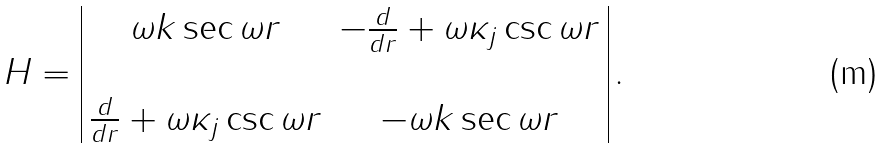Convert formula to latex. <formula><loc_0><loc_0><loc_500><loc_500>H = \begin{array} { | c c | } \omega k \sec \omega r & - \frac { d } { d r } + \omega \kappa _ { j } \csc \omega r \\ & \\ \frac { d } { d r } + \omega \kappa _ { j } \csc \omega r & - \omega k \sec \omega r \end{array} \, .</formula> 